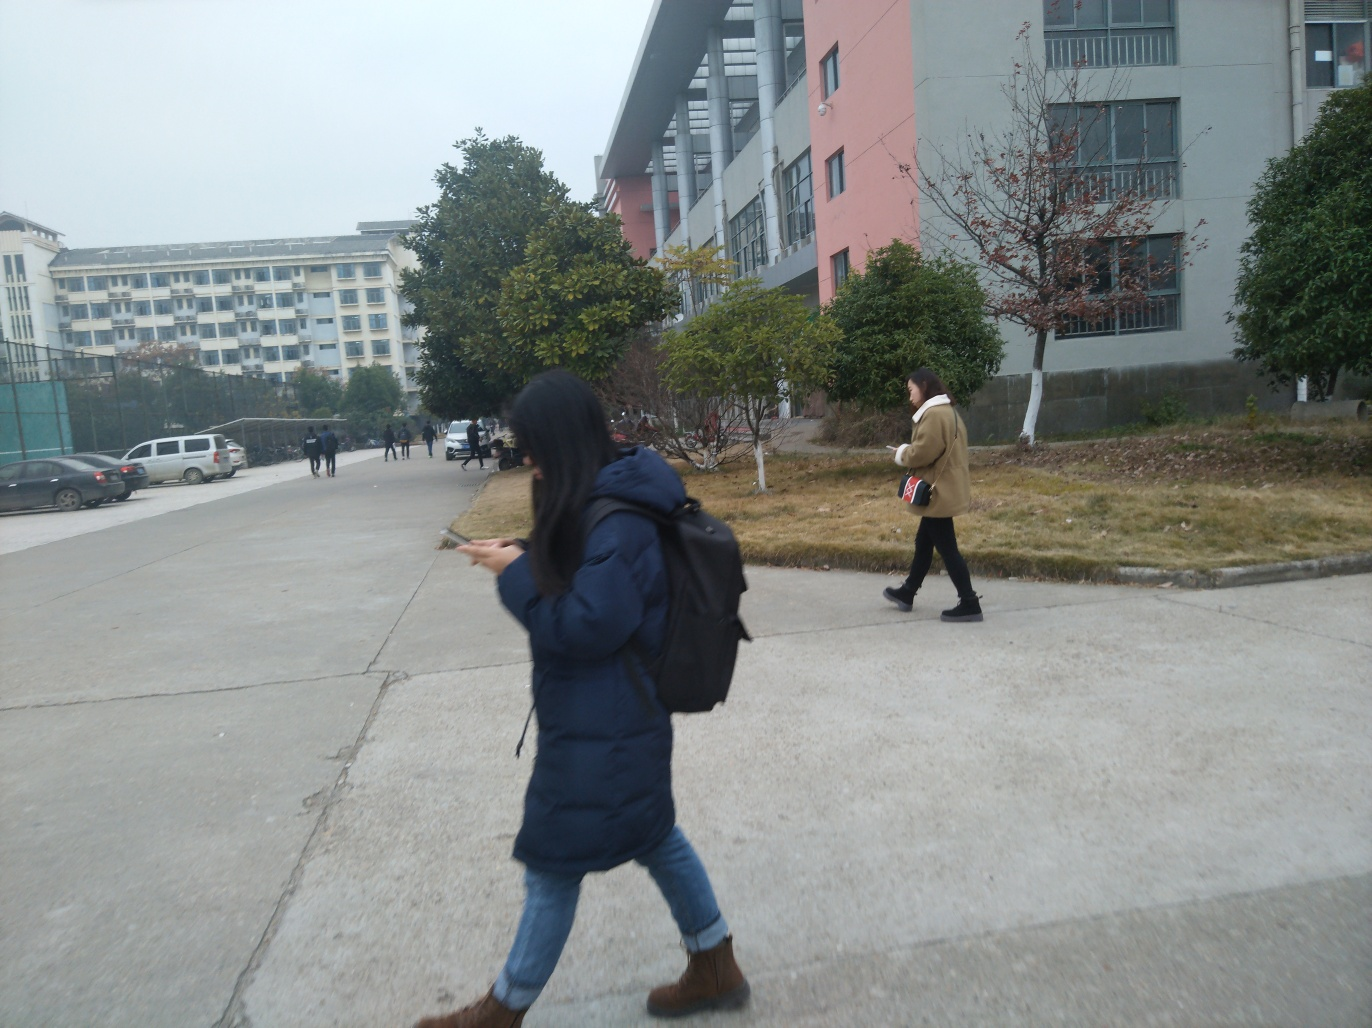What time of the year does this scene seem to represent? Based on the attire of the individuals in the image, wearing jackets and long pants, this scene likely represents a cooler season, possibly autumn or winter. 